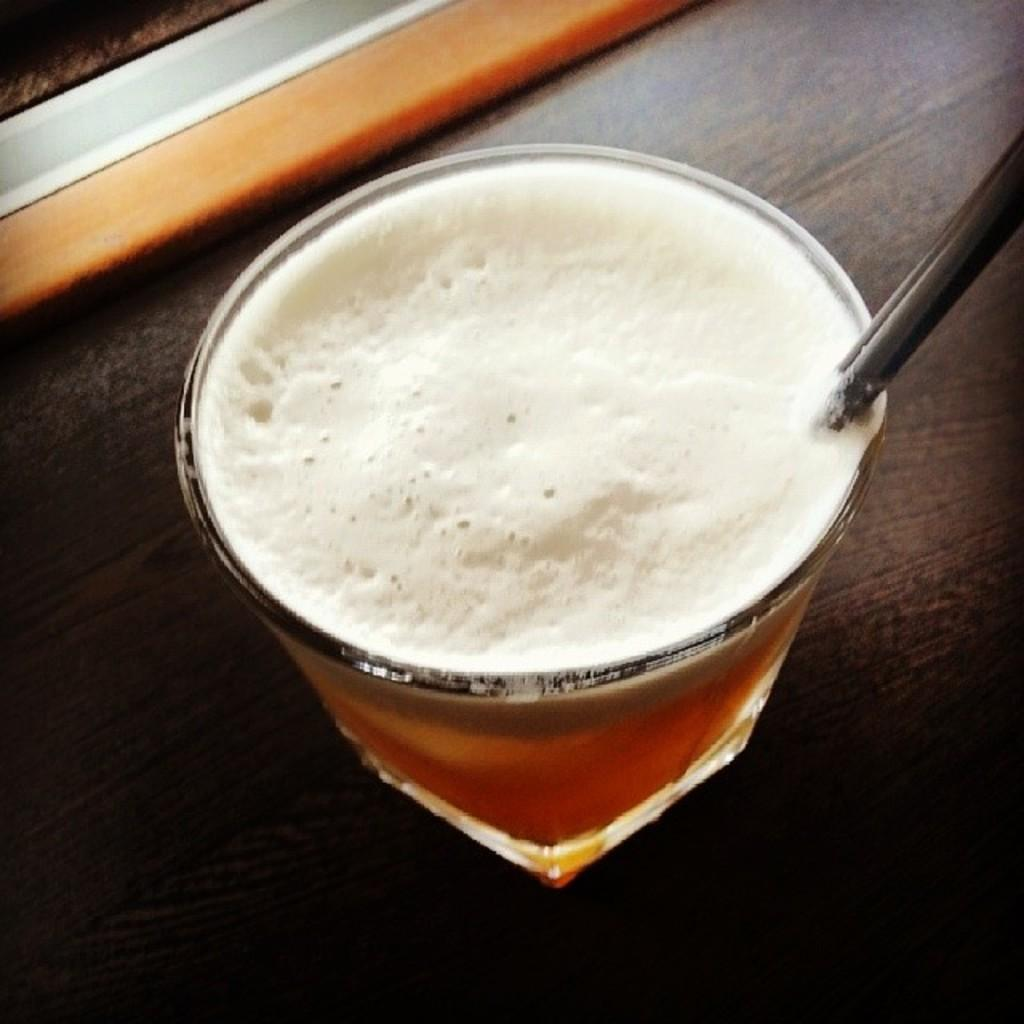What is inside the glass that is visible in the image? There is a glass with liquid in the image. What can be found inside the glass? There is an object in the glass. Where is the glass placed in the image? The glass is on a platform. What is located on the left at the top of the image? There is an object on the left at the top of the image. What is the reason for the glass being hot in the image? The image does not mention the glass being hot, nor does it provide any information about the temperature of the glass. 